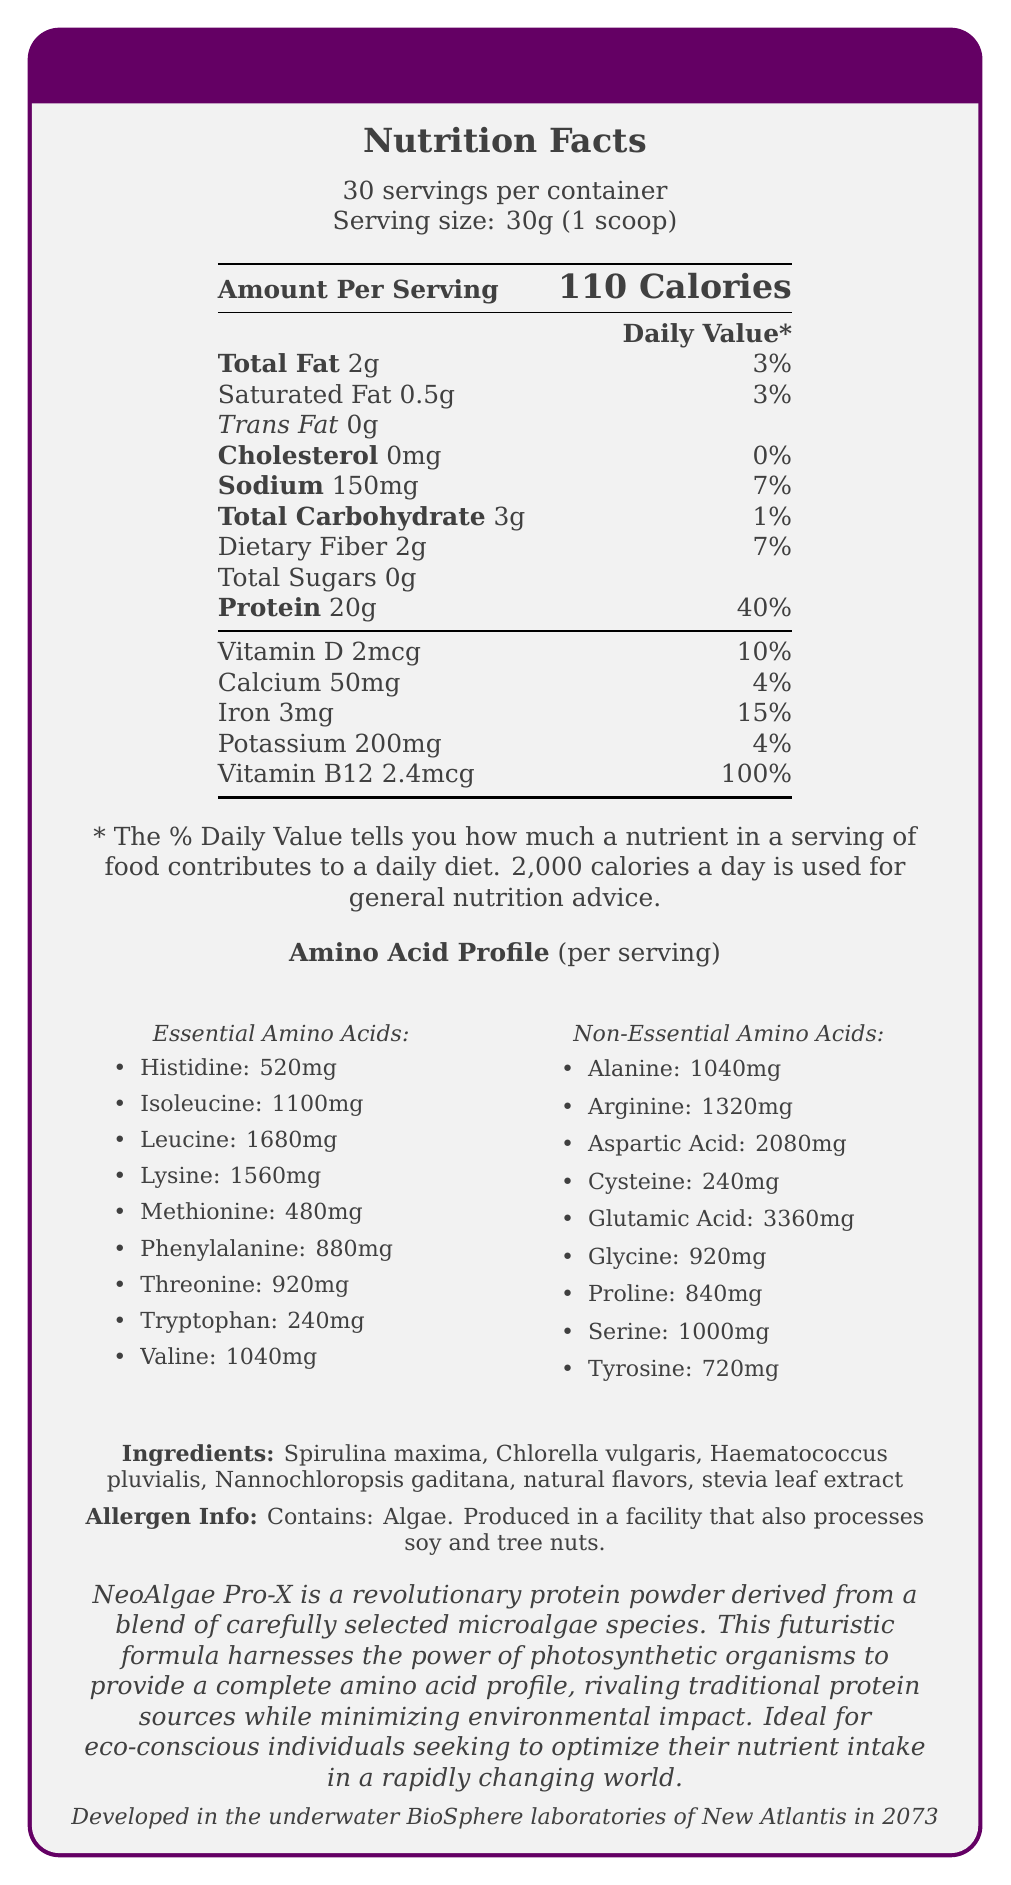What is the serving size of NeoAlgae Pro-X? The serving size is explicitly stated as 30g, which is equal to one scoop.
Answer: 30g (1 scoop) How many calories are in one serving of NeoAlgae Pro-X? The document indicates that one serving of NeoAlgae Pro-X contains 110 calories.
Answer: 110 calories Name two essential amino acids present in NeoAlgae Pro-X and their respective amounts. The essential amino acids and their quantities per serving are listed in the document. Leucine has 1680mg, and Lysine has 1560mg per serving.
Answer: Leucine: 1680mg, Lysine: 1560mg Does NeoAlgae Pro-X contain any cholesterol? The document specifies that NeoAlgae Pro-X contains 0mg of cholesterol.
Answer: No What is the total fat content in a serving of NeoAlgae Pro-X? The total fat content per serving is 2g as specified in the nutrition facts.
Answer: 2g Which of the following is an ingredient in NeoAlgae Pro-X? A. Whey protein B. Soy protein C. Spirulina maxima D. Casein The ingredients listed include Spirulina maxima, making it the correct option.
Answer: C. Spirulina maxima What is the daily value percentage of Vitamin B12 in one serving of NeoAlgae Pro-X? A. 10% B. 50% C. 100% D. 150% The document shows that Vitamin B12 has a daily value percentage of 100% per serving.
Answer: C. 100% Can consuming NeoAlgae Pro-X contribute to dietary fiber intake? The document states that each serving contains 2g of dietary fiber, which is 7% of the daily value.
Answer: Yes Summarize the main idea of the NeoAlgae Pro-X document. The document provides detailed nutritional information, an amino acid profile, a list of ingredients, allergen information, and a product description emphasizing its sustainability and development background.
Answer: NeoAlgae Pro-X is a futuristic algae-based protein powder providing a complete amino acid profile with detailed nutrition and ingredient information, highlighting its sustainable and eco-friendly production. Where was NeoAlgae Pro-X developed, according to its fictional backstory? The fictional backstory section explicitly mentions that NeoAlgae Pro-X was developed in the underwater BioSphere laboratories of New Atlantis in 2073.
Answer: Underwater BioSphere laboratories of New Atlantis in 2073 What is the Vitamin D content in one serving, and what is its daily value percentage? The document lists the Vitamin D content as 2mcg per serving, which provides 10% of the daily value.
Answer: 2mcg, 10% How many non-essential amino acids are listed in the NeoAlgae Pro-X amino acid profile? The document lists 9 non-essential amino acids in the amino acid profile section.
Answer: 9 Which amino acid has the highest amount per serving in NeoAlgae Pro-X? Glutamic Acid has the highest amount per serving at 3360mg, according to the amino acid profile.
Answer: Glutamic Acid: 3360mg What are the environmental benefits of NeoAlgae Pro-X mentioned in the product description? The product description notes that NeoAlgae Pro-X minimizes environmental impact by providing a sustainable protein source.
Answer: Minimizes environmental impact Is NeoAlgae Pro-X suitable for individuals allergic to algae? The allergen information clearly states that the product contains algae.
Answer: No How much sodium does one serving of NeoAlgae Pro-X contain? The nutrition facts indicate that each serving contains 150mg of sodium.
Answer: 150mg What is the source of the sweetness in NeoAlgae Pro-X? Stevia leaf extract is listed among the ingredients, indicating it is used as a sweetener.
Answer: Stevia leaf extract Why was NeoAlgae Pro-X developed according to the fictional backstory? The fictional backstory explains that NeoAlgae Pro-X was designed to meet the nutritional needs of space colonists and deep-sea settlers.
Answer: To meet the nutritional demands of space colonists and deep-sea settlers 